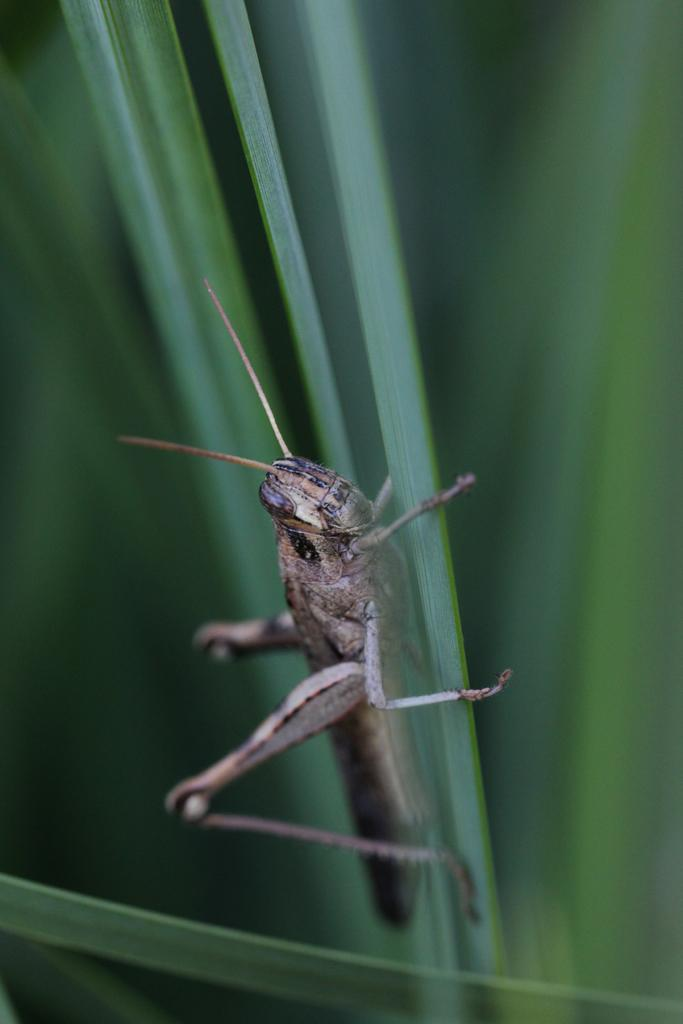What type of creature can be seen in the image? There is an insect in the image. Where is the insect located? The insect is on a plant. What is the position of the insect and plant in the image? The insect and plant are in the center of the image. What type of hydrant is visible in the image? There is no hydrant present in the image; it features an insect on a plant. Can you tell me the shape of the heart in the image? There is no heart present in the image; it features an insect on a plant. 